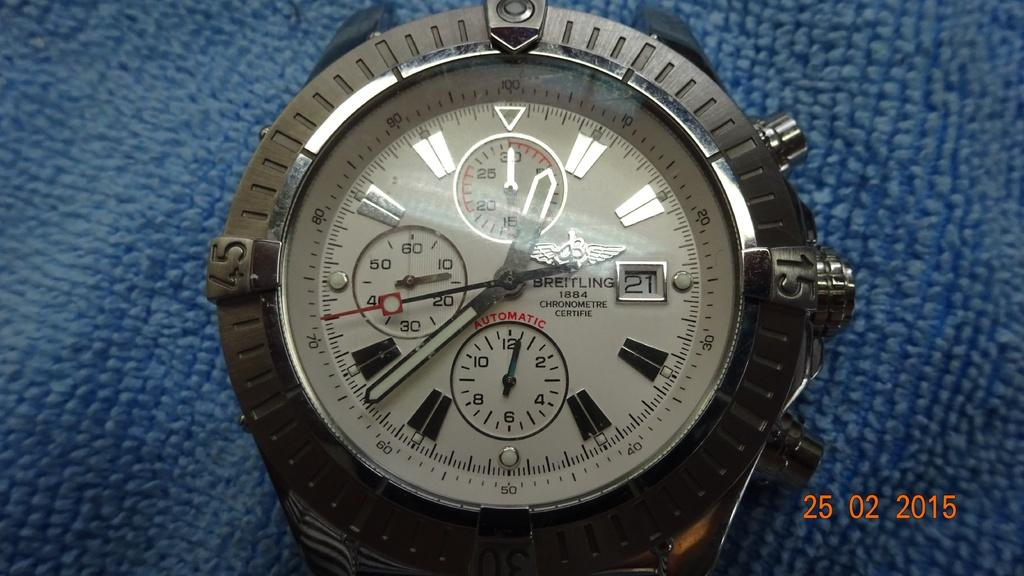<image>
Offer a succinct explanation of the picture presented. A watch that says Breitling on the watch face and is black and white. 